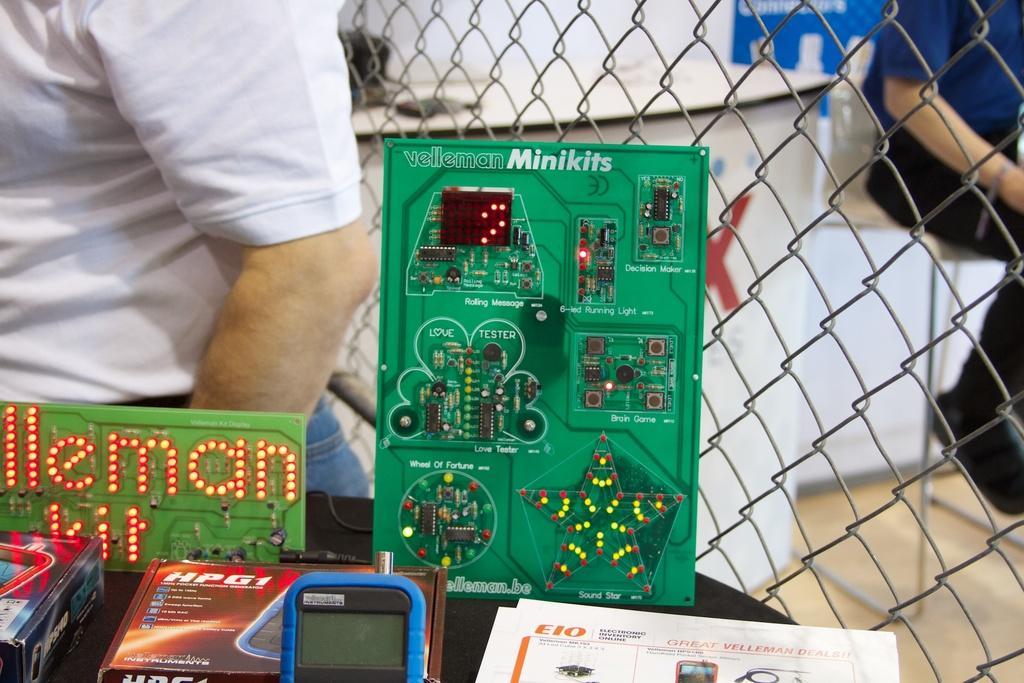Please provide a concise description of this image. In this image there are two persons and there is an electric kit. In front of it there are boxes and paper. Beside that, there is a fence and a table, on top of the table there is a bag. And there is a chair, the person sitting on it. 